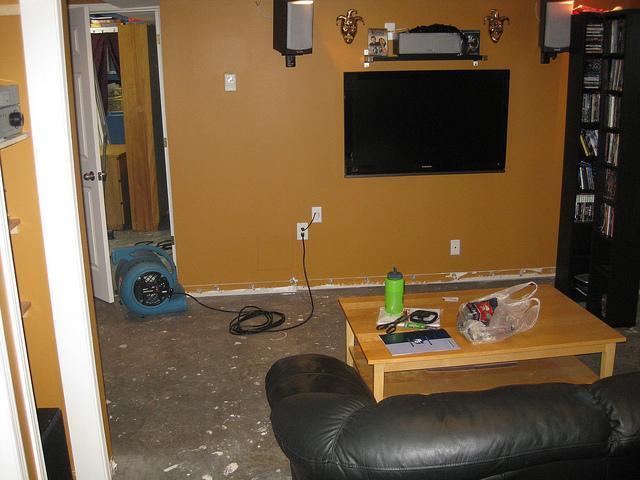How many chairs are there?
Give a very brief answer. 0. 